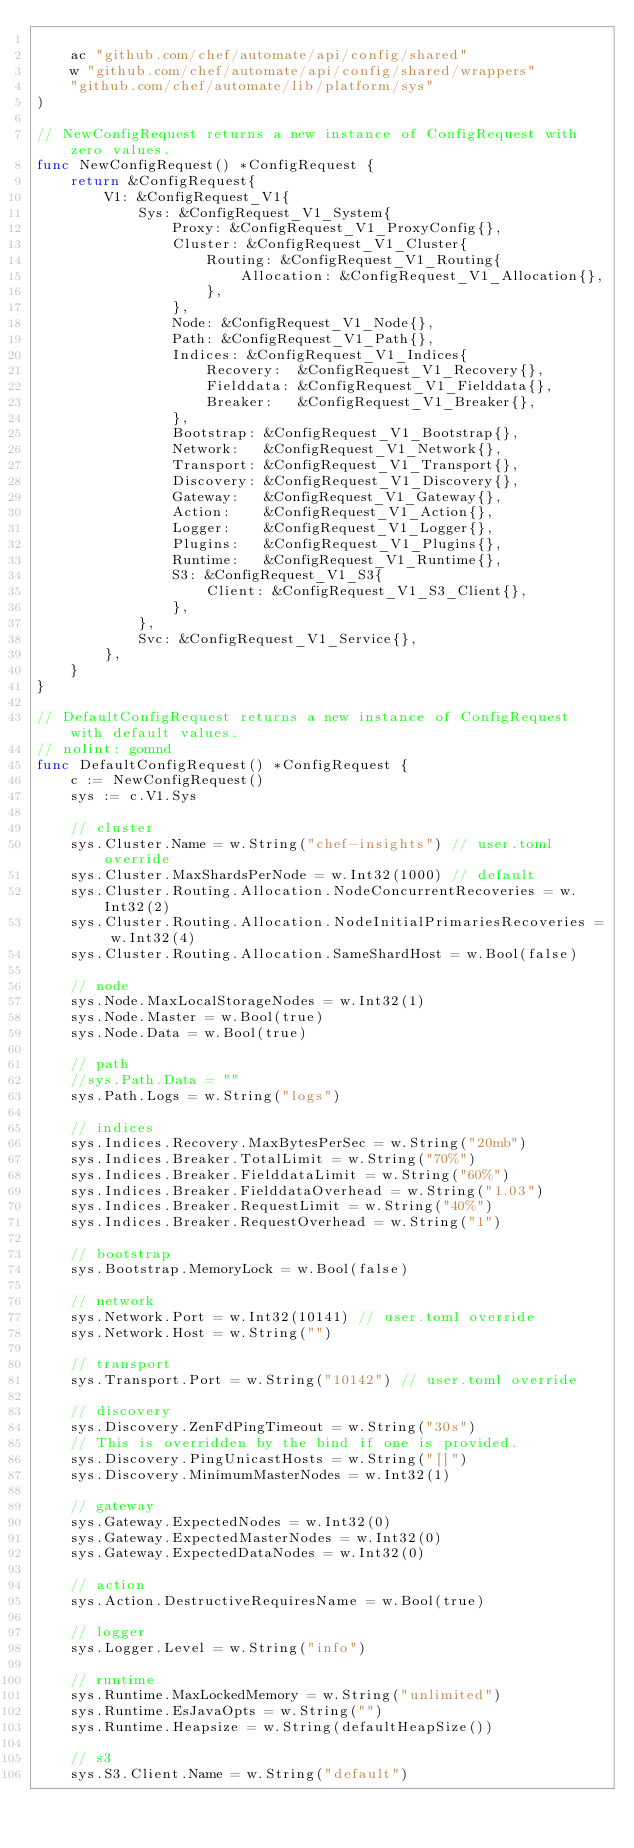<code> <loc_0><loc_0><loc_500><loc_500><_Go_>
	ac "github.com/chef/automate/api/config/shared"
	w "github.com/chef/automate/api/config/shared/wrappers"
	"github.com/chef/automate/lib/platform/sys"
)

// NewConfigRequest returns a new instance of ConfigRequest with zero values.
func NewConfigRequest() *ConfigRequest {
	return &ConfigRequest{
		V1: &ConfigRequest_V1{
			Sys: &ConfigRequest_V1_System{
				Proxy: &ConfigRequest_V1_ProxyConfig{},
				Cluster: &ConfigRequest_V1_Cluster{
					Routing: &ConfigRequest_V1_Routing{
						Allocation: &ConfigRequest_V1_Allocation{},
					},
				},
				Node: &ConfigRequest_V1_Node{},
				Path: &ConfigRequest_V1_Path{},
				Indices: &ConfigRequest_V1_Indices{
					Recovery:  &ConfigRequest_V1_Recovery{},
					Fielddata: &ConfigRequest_V1_Fielddata{},
					Breaker:   &ConfigRequest_V1_Breaker{},
				},
				Bootstrap: &ConfigRequest_V1_Bootstrap{},
				Network:   &ConfigRequest_V1_Network{},
				Transport: &ConfigRequest_V1_Transport{},
				Discovery: &ConfigRequest_V1_Discovery{},
				Gateway:   &ConfigRequest_V1_Gateway{},
				Action:    &ConfigRequest_V1_Action{},
				Logger:    &ConfigRequest_V1_Logger{},
				Plugins:   &ConfigRequest_V1_Plugins{},
				Runtime:   &ConfigRequest_V1_Runtime{},
				S3: &ConfigRequest_V1_S3{
					Client: &ConfigRequest_V1_S3_Client{},
				},
			},
			Svc: &ConfigRequest_V1_Service{},
		},
	}
}

// DefaultConfigRequest returns a new instance of ConfigRequest with default values.
// nolint: gomnd
func DefaultConfigRequest() *ConfigRequest {
	c := NewConfigRequest()
	sys := c.V1.Sys

	// cluster
	sys.Cluster.Name = w.String("chef-insights") // user.toml override
	sys.Cluster.MaxShardsPerNode = w.Int32(1000) // default
	sys.Cluster.Routing.Allocation.NodeConcurrentRecoveries = w.Int32(2)
	sys.Cluster.Routing.Allocation.NodeInitialPrimariesRecoveries = w.Int32(4)
	sys.Cluster.Routing.Allocation.SameShardHost = w.Bool(false)

	// node
	sys.Node.MaxLocalStorageNodes = w.Int32(1)
	sys.Node.Master = w.Bool(true)
	sys.Node.Data = w.Bool(true)

	// path
	//sys.Path.Data = ""
	sys.Path.Logs = w.String("logs")

	// indices
	sys.Indices.Recovery.MaxBytesPerSec = w.String("20mb")
	sys.Indices.Breaker.TotalLimit = w.String("70%")
	sys.Indices.Breaker.FielddataLimit = w.String("60%")
	sys.Indices.Breaker.FielddataOverhead = w.String("1.03")
	sys.Indices.Breaker.RequestLimit = w.String("40%")
	sys.Indices.Breaker.RequestOverhead = w.String("1")

	// bootstrap
	sys.Bootstrap.MemoryLock = w.Bool(false)

	// network
	sys.Network.Port = w.Int32(10141) // user.toml override
	sys.Network.Host = w.String("")

	// transport
	sys.Transport.Port = w.String("10142") // user.toml override

	// discovery
	sys.Discovery.ZenFdPingTimeout = w.String("30s")
	// This is overridden by the bind if one is provided.
	sys.Discovery.PingUnicastHosts = w.String("[]")
	sys.Discovery.MinimumMasterNodes = w.Int32(1)

	// gateway
	sys.Gateway.ExpectedNodes = w.Int32(0)
	sys.Gateway.ExpectedMasterNodes = w.Int32(0)
	sys.Gateway.ExpectedDataNodes = w.Int32(0)

	// action
	sys.Action.DestructiveRequiresName = w.Bool(true)

	// logger
	sys.Logger.Level = w.String("info")

	// runtime
	sys.Runtime.MaxLockedMemory = w.String("unlimited")
	sys.Runtime.EsJavaOpts = w.String("")
	sys.Runtime.Heapsize = w.String(defaultHeapSize())

	// s3
	sys.S3.Client.Name = w.String("default")</code> 